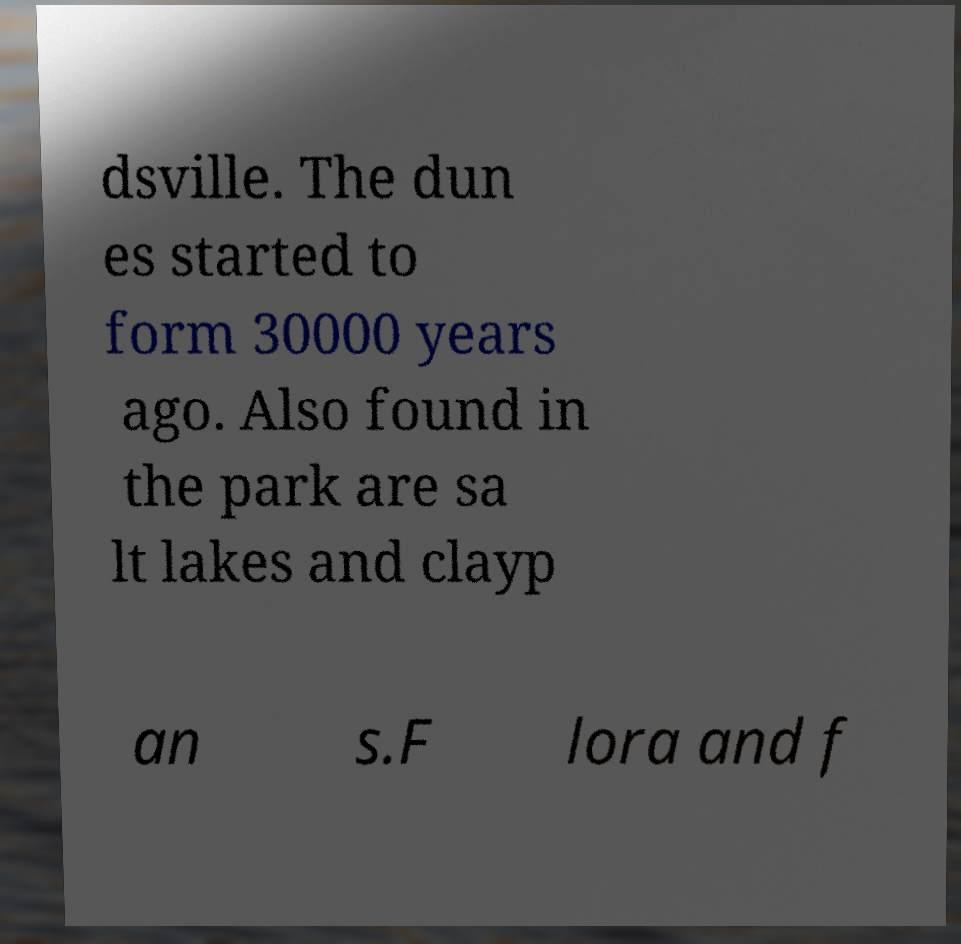Can you accurately transcribe the text from the provided image for me? dsville. The dun es started to form 30000 years ago. Also found in the park are sa lt lakes and clayp an s.F lora and f 